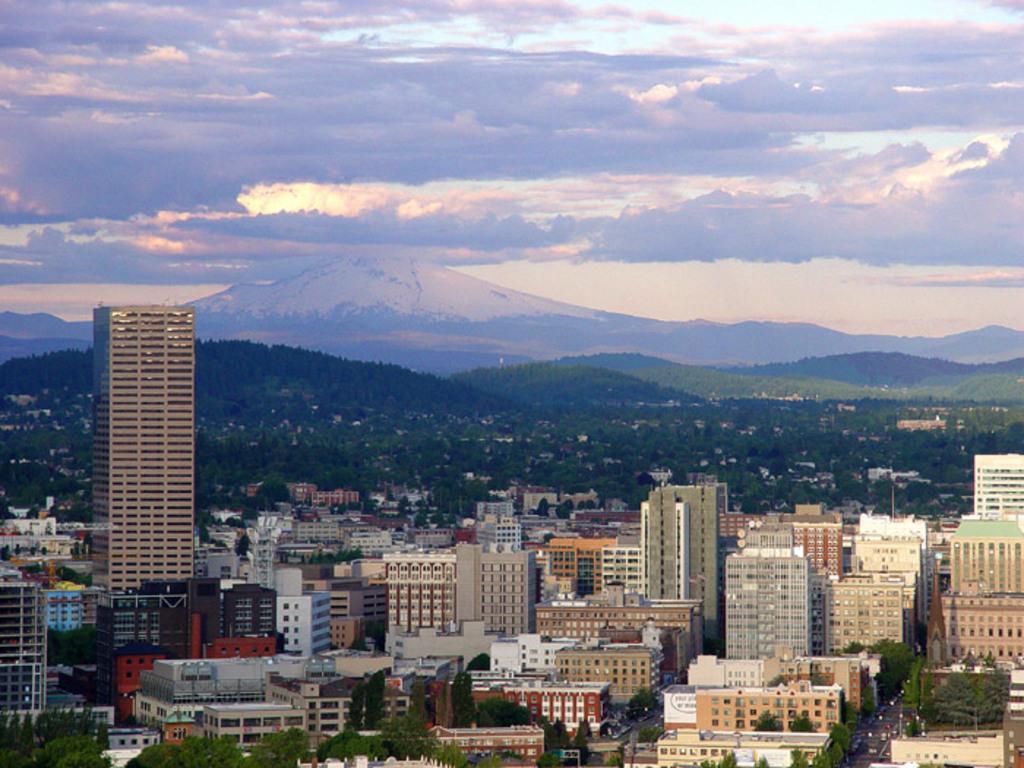Could you give a brief overview of what you see in this image? In this image I can see number of buildings, number of trees, mountains, clouds and the sky in background. 